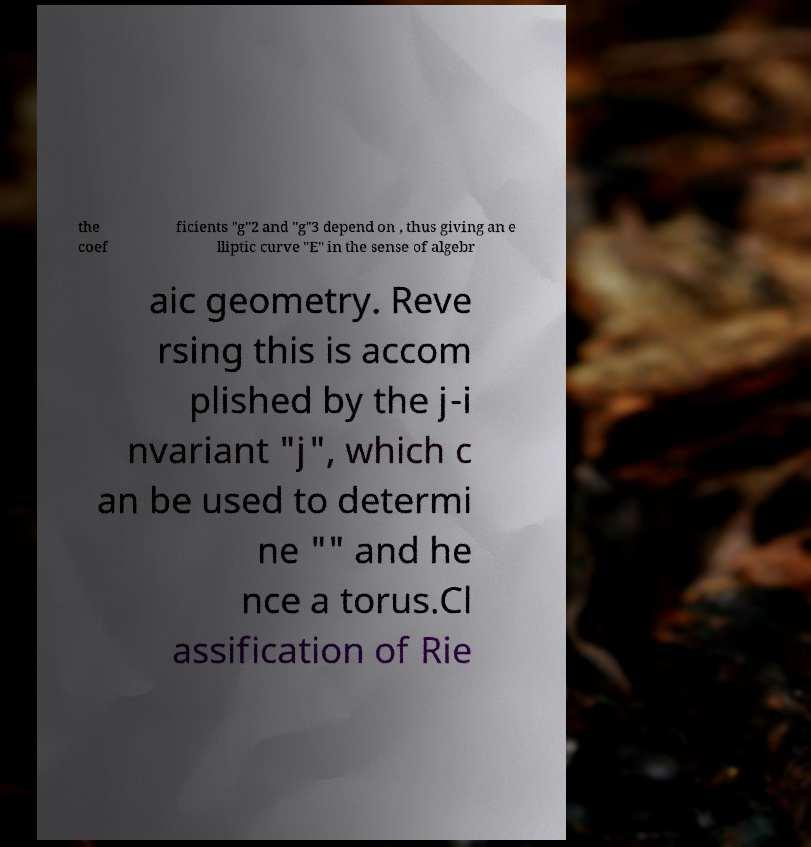Could you extract and type out the text from this image? the coef ficients "g"2 and "g"3 depend on , thus giving an e lliptic curve "E" in the sense of algebr aic geometry. Reve rsing this is accom plished by the j-i nvariant "j", which c an be used to determi ne "" and he nce a torus.Cl assification of Rie 